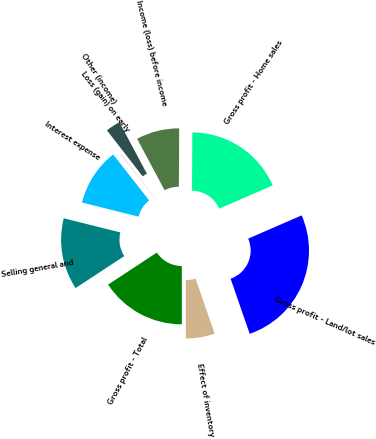Convert chart to OTSL. <chart><loc_0><loc_0><loc_500><loc_500><pie_chart><fcel>Gross profit - Home sales<fcel>Gross profit - Land/lot sales<fcel>Effect of inventory<fcel>Gross profit - Total<fcel>Selling general and<fcel>Interest expense<fcel>Loss (gain) on early<fcel>Other (income)<fcel>Income (loss) before income<nl><fcel>18.38%<fcel>26.22%<fcel>5.3%<fcel>15.76%<fcel>13.15%<fcel>10.53%<fcel>0.07%<fcel>2.68%<fcel>7.91%<nl></chart> 